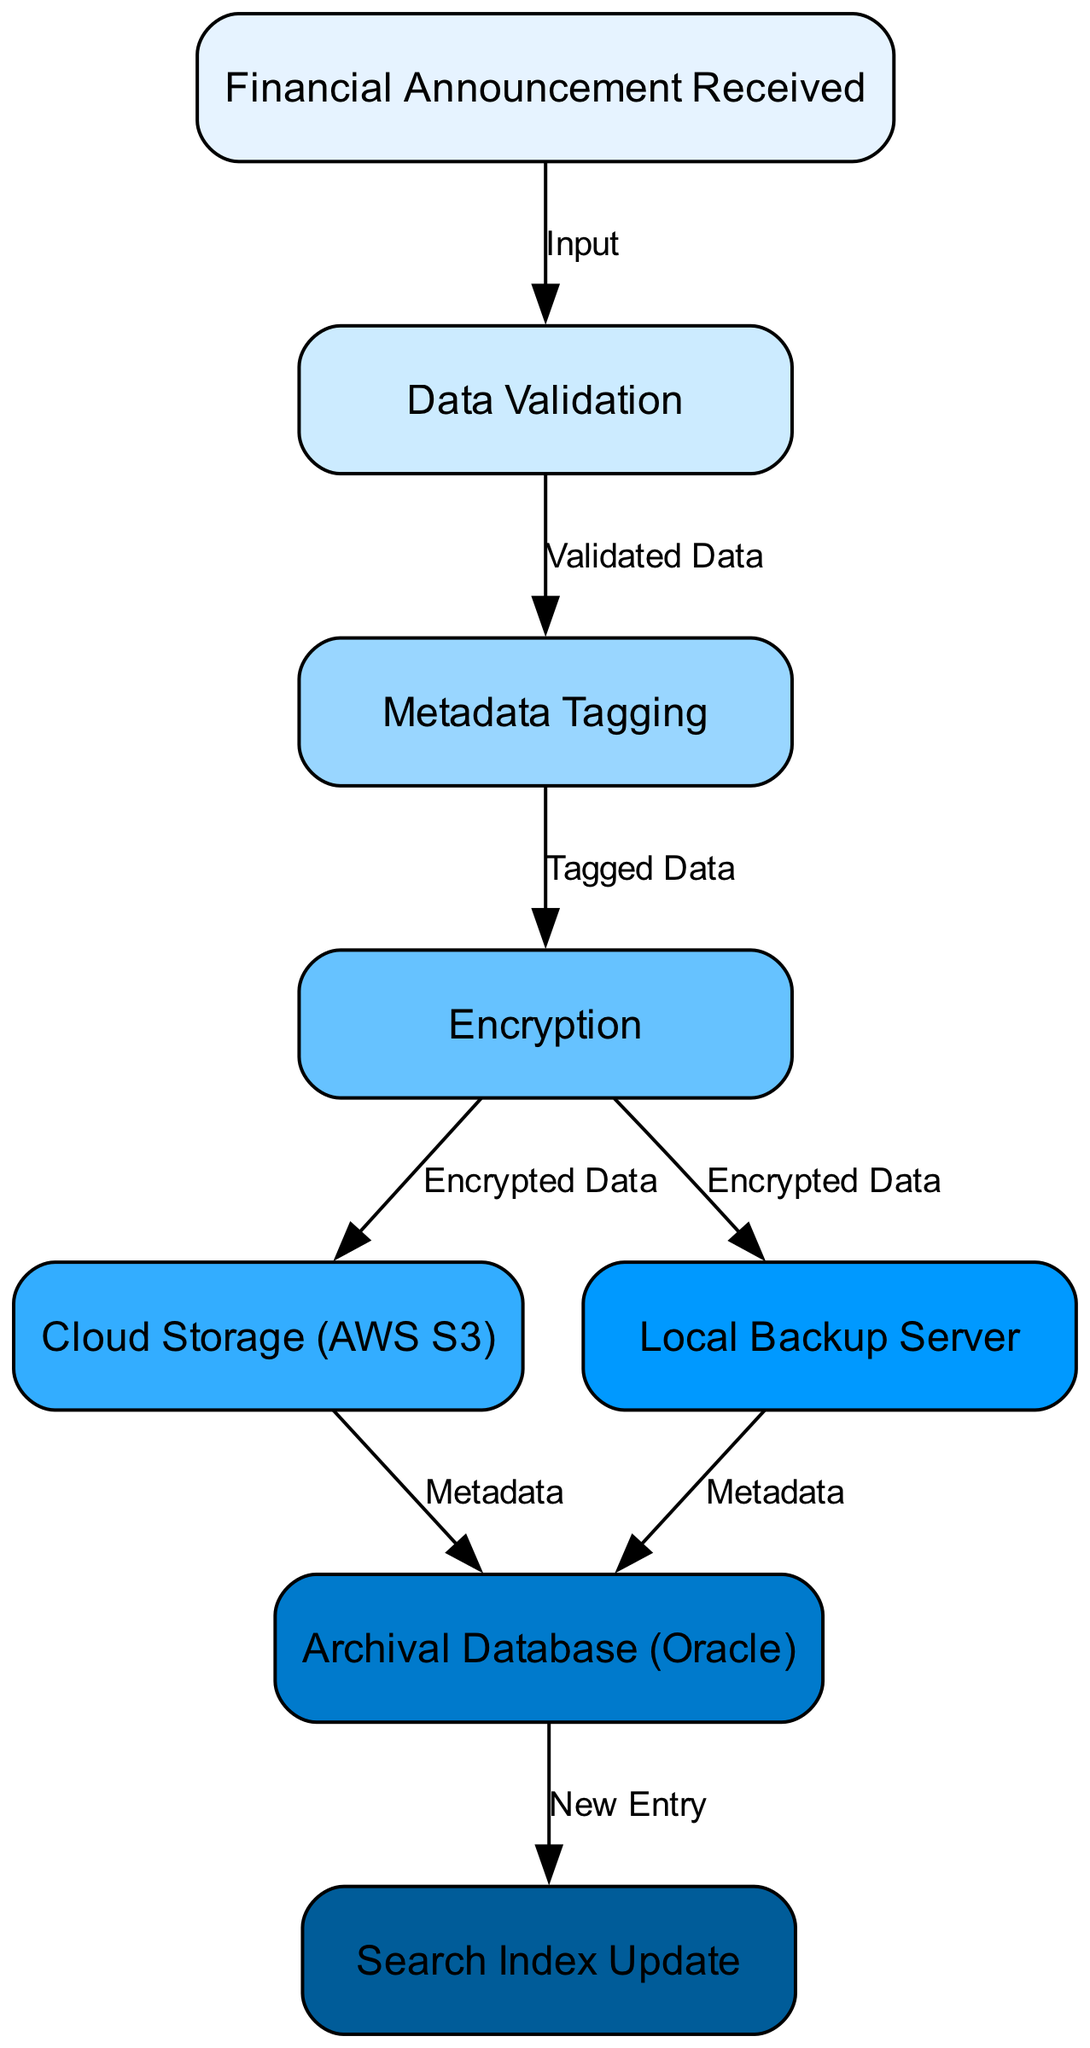What is the starting point of the flow? The starting point is the first node labeled "Financial Announcement Received," which indicates the initiation of the process flow in the diagram.
Answer: Financial Announcement Received How many nodes are present in the diagram? By counting each unique node representation in the diagram, there are eight nodes denoted.
Answer: 8 What is the node immediately following Data Validation? The flow from the "Data Validation" node leads to the "Metadata Tagging" node, which directly follows it in the process.
Answer: Metadata Tagging What process occurs after Encryption? From the "Encryption" node, the flow diverges, leading to two destinations: "Cloud Storage (AWS S3)" and "Local Backup Server."
Answer: Cloud Storage (AWS S3) and Local Backup Server Which node is responsible for updating the search index? The node labeled "Search Index Update" is the one designated for updating the search index at the end of the archival process depicted in the diagram.
Answer: Search Index Update How do the nodes Cloud Storage and Local Backup relate to the Archival Database? Both "Cloud Storage (AWS S3)" and "Local Backup Server" feed into the "Archival Database (Oracle)," with the metadata being the link connecting them to the archival storage.
Answer: Metadata What label connects from Encryption to Local Backup Server? The label on the edge that directs from the "Encryption" node to the "Local Backup Server" indicates that it carries "Encrypted Data."
Answer: Encrypted Data 